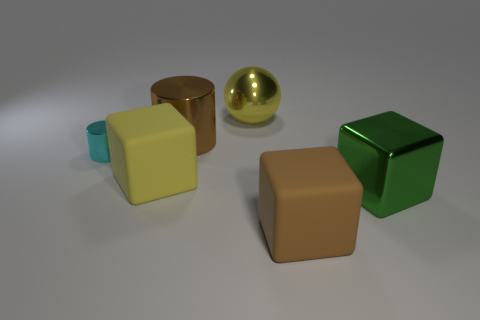Add 3 green balls. How many objects exist? 9 Subtract all spheres. How many objects are left? 5 Subtract 0 red cylinders. How many objects are left? 6 Subtract all small purple shiny blocks. Subtract all large metal objects. How many objects are left? 3 Add 3 big brown rubber objects. How many big brown rubber objects are left? 4 Add 5 small cyan things. How many small cyan things exist? 6 